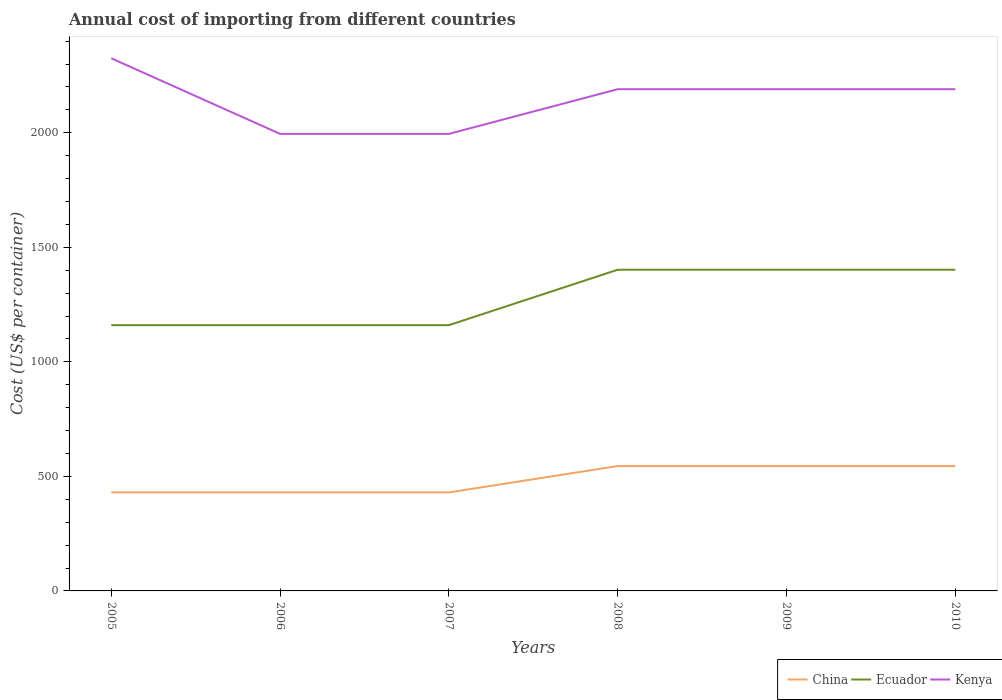Across all years, what is the maximum total annual cost of importing in Ecuador?
Make the answer very short. 1160. In which year was the total annual cost of importing in China maximum?
Provide a succinct answer. 2005. What is the total total annual cost of importing in Kenya in the graph?
Your answer should be compact. 135. What is the difference between the highest and the second highest total annual cost of importing in Kenya?
Keep it short and to the point. 330. What is the difference between the highest and the lowest total annual cost of importing in Ecuador?
Your response must be concise. 3. Is the total annual cost of importing in Kenya strictly greater than the total annual cost of importing in China over the years?
Provide a short and direct response. No. Are the values on the major ticks of Y-axis written in scientific E-notation?
Offer a very short reply. No. Does the graph contain any zero values?
Provide a succinct answer. No. Where does the legend appear in the graph?
Your response must be concise. Bottom right. How many legend labels are there?
Keep it short and to the point. 3. What is the title of the graph?
Offer a very short reply. Annual cost of importing from different countries. What is the label or title of the Y-axis?
Your response must be concise. Cost (US$ per container). What is the Cost (US$ per container) of China in 2005?
Your answer should be very brief. 430. What is the Cost (US$ per container) in Ecuador in 2005?
Your answer should be very brief. 1160. What is the Cost (US$ per container) in Kenya in 2005?
Offer a very short reply. 2325. What is the Cost (US$ per container) in China in 2006?
Give a very brief answer. 430. What is the Cost (US$ per container) of Ecuador in 2006?
Provide a succinct answer. 1160. What is the Cost (US$ per container) of Kenya in 2006?
Keep it short and to the point. 1995. What is the Cost (US$ per container) in China in 2007?
Your response must be concise. 430. What is the Cost (US$ per container) in Ecuador in 2007?
Ensure brevity in your answer.  1160. What is the Cost (US$ per container) in Kenya in 2007?
Keep it short and to the point. 1995. What is the Cost (US$ per container) of China in 2008?
Your response must be concise. 545. What is the Cost (US$ per container) of Ecuador in 2008?
Offer a terse response. 1402. What is the Cost (US$ per container) in Kenya in 2008?
Your answer should be compact. 2190. What is the Cost (US$ per container) in China in 2009?
Offer a terse response. 545. What is the Cost (US$ per container) of Ecuador in 2009?
Offer a terse response. 1402. What is the Cost (US$ per container) in Kenya in 2009?
Offer a terse response. 2190. What is the Cost (US$ per container) of China in 2010?
Provide a short and direct response. 545. What is the Cost (US$ per container) of Ecuador in 2010?
Ensure brevity in your answer.  1402. What is the Cost (US$ per container) in Kenya in 2010?
Your response must be concise. 2190. Across all years, what is the maximum Cost (US$ per container) of China?
Give a very brief answer. 545. Across all years, what is the maximum Cost (US$ per container) in Ecuador?
Your response must be concise. 1402. Across all years, what is the maximum Cost (US$ per container) in Kenya?
Your answer should be very brief. 2325. Across all years, what is the minimum Cost (US$ per container) in China?
Offer a terse response. 430. Across all years, what is the minimum Cost (US$ per container) in Ecuador?
Give a very brief answer. 1160. Across all years, what is the minimum Cost (US$ per container) in Kenya?
Provide a succinct answer. 1995. What is the total Cost (US$ per container) of China in the graph?
Your answer should be compact. 2925. What is the total Cost (US$ per container) in Ecuador in the graph?
Offer a very short reply. 7686. What is the total Cost (US$ per container) of Kenya in the graph?
Make the answer very short. 1.29e+04. What is the difference between the Cost (US$ per container) in China in 2005 and that in 2006?
Your answer should be very brief. 0. What is the difference between the Cost (US$ per container) of Kenya in 2005 and that in 2006?
Provide a short and direct response. 330. What is the difference between the Cost (US$ per container) of Ecuador in 2005 and that in 2007?
Provide a short and direct response. 0. What is the difference between the Cost (US$ per container) in Kenya in 2005 and that in 2007?
Your answer should be very brief. 330. What is the difference between the Cost (US$ per container) in China in 2005 and that in 2008?
Make the answer very short. -115. What is the difference between the Cost (US$ per container) of Ecuador in 2005 and that in 2008?
Keep it short and to the point. -242. What is the difference between the Cost (US$ per container) in Kenya in 2005 and that in 2008?
Offer a very short reply. 135. What is the difference between the Cost (US$ per container) in China in 2005 and that in 2009?
Your response must be concise. -115. What is the difference between the Cost (US$ per container) in Ecuador in 2005 and that in 2009?
Offer a very short reply. -242. What is the difference between the Cost (US$ per container) of Kenya in 2005 and that in 2009?
Your answer should be very brief. 135. What is the difference between the Cost (US$ per container) in China in 2005 and that in 2010?
Provide a succinct answer. -115. What is the difference between the Cost (US$ per container) of Ecuador in 2005 and that in 2010?
Offer a terse response. -242. What is the difference between the Cost (US$ per container) in Kenya in 2005 and that in 2010?
Give a very brief answer. 135. What is the difference between the Cost (US$ per container) of China in 2006 and that in 2007?
Make the answer very short. 0. What is the difference between the Cost (US$ per container) in Ecuador in 2006 and that in 2007?
Provide a short and direct response. 0. What is the difference between the Cost (US$ per container) of China in 2006 and that in 2008?
Your response must be concise. -115. What is the difference between the Cost (US$ per container) of Ecuador in 2006 and that in 2008?
Provide a succinct answer. -242. What is the difference between the Cost (US$ per container) in Kenya in 2006 and that in 2008?
Your response must be concise. -195. What is the difference between the Cost (US$ per container) of China in 2006 and that in 2009?
Keep it short and to the point. -115. What is the difference between the Cost (US$ per container) of Ecuador in 2006 and that in 2009?
Your answer should be very brief. -242. What is the difference between the Cost (US$ per container) in Kenya in 2006 and that in 2009?
Offer a terse response. -195. What is the difference between the Cost (US$ per container) in China in 2006 and that in 2010?
Ensure brevity in your answer.  -115. What is the difference between the Cost (US$ per container) of Ecuador in 2006 and that in 2010?
Give a very brief answer. -242. What is the difference between the Cost (US$ per container) of Kenya in 2006 and that in 2010?
Your answer should be very brief. -195. What is the difference between the Cost (US$ per container) in China in 2007 and that in 2008?
Provide a short and direct response. -115. What is the difference between the Cost (US$ per container) of Ecuador in 2007 and that in 2008?
Ensure brevity in your answer.  -242. What is the difference between the Cost (US$ per container) in Kenya in 2007 and that in 2008?
Your answer should be compact. -195. What is the difference between the Cost (US$ per container) of China in 2007 and that in 2009?
Offer a very short reply. -115. What is the difference between the Cost (US$ per container) of Ecuador in 2007 and that in 2009?
Provide a short and direct response. -242. What is the difference between the Cost (US$ per container) in Kenya in 2007 and that in 2009?
Keep it short and to the point. -195. What is the difference between the Cost (US$ per container) in China in 2007 and that in 2010?
Provide a short and direct response. -115. What is the difference between the Cost (US$ per container) of Ecuador in 2007 and that in 2010?
Your response must be concise. -242. What is the difference between the Cost (US$ per container) of Kenya in 2007 and that in 2010?
Keep it short and to the point. -195. What is the difference between the Cost (US$ per container) of China in 2008 and that in 2009?
Keep it short and to the point. 0. What is the difference between the Cost (US$ per container) of Kenya in 2008 and that in 2009?
Your response must be concise. 0. What is the difference between the Cost (US$ per container) in Kenya in 2008 and that in 2010?
Offer a very short reply. 0. What is the difference between the Cost (US$ per container) of China in 2009 and that in 2010?
Keep it short and to the point. 0. What is the difference between the Cost (US$ per container) of China in 2005 and the Cost (US$ per container) of Ecuador in 2006?
Your answer should be very brief. -730. What is the difference between the Cost (US$ per container) of China in 2005 and the Cost (US$ per container) of Kenya in 2006?
Your answer should be compact. -1565. What is the difference between the Cost (US$ per container) in Ecuador in 2005 and the Cost (US$ per container) in Kenya in 2006?
Ensure brevity in your answer.  -835. What is the difference between the Cost (US$ per container) in China in 2005 and the Cost (US$ per container) in Ecuador in 2007?
Offer a very short reply. -730. What is the difference between the Cost (US$ per container) in China in 2005 and the Cost (US$ per container) in Kenya in 2007?
Give a very brief answer. -1565. What is the difference between the Cost (US$ per container) in Ecuador in 2005 and the Cost (US$ per container) in Kenya in 2007?
Keep it short and to the point. -835. What is the difference between the Cost (US$ per container) in China in 2005 and the Cost (US$ per container) in Ecuador in 2008?
Ensure brevity in your answer.  -972. What is the difference between the Cost (US$ per container) in China in 2005 and the Cost (US$ per container) in Kenya in 2008?
Keep it short and to the point. -1760. What is the difference between the Cost (US$ per container) of Ecuador in 2005 and the Cost (US$ per container) of Kenya in 2008?
Your answer should be very brief. -1030. What is the difference between the Cost (US$ per container) in China in 2005 and the Cost (US$ per container) in Ecuador in 2009?
Offer a terse response. -972. What is the difference between the Cost (US$ per container) of China in 2005 and the Cost (US$ per container) of Kenya in 2009?
Ensure brevity in your answer.  -1760. What is the difference between the Cost (US$ per container) in Ecuador in 2005 and the Cost (US$ per container) in Kenya in 2009?
Ensure brevity in your answer.  -1030. What is the difference between the Cost (US$ per container) in China in 2005 and the Cost (US$ per container) in Ecuador in 2010?
Offer a very short reply. -972. What is the difference between the Cost (US$ per container) of China in 2005 and the Cost (US$ per container) of Kenya in 2010?
Your response must be concise. -1760. What is the difference between the Cost (US$ per container) in Ecuador in 2005 and the Cost (US$ per container) in Kenya in 2010?
Provide a short and direct response. -1030. What is the difference between the Cost (US$ per container) of China in 2006 and the Cost (US$ per container) of Ecuador in 2007?
Offer a very short reply. -730. What is the difference between the Cost (US$ per container) in China in 2006 and the Cost (US$ per container) in Kenya in 2007?
Your answer should be very brief. -1565. What is the difference between the Cost (US$ per container) in Ecuador in 2006 and the Cost (US$ per container) in Kenya in 2007?
Your response must be concise. -835. What is the difference between the Cost (US$ per container) in China in 2006 and the Cost (US$ per container) in Ecuador in 2008?
Offer a terse response. -972. What is the difference between the Cost (US$ per container) in China in 2006 and the Cost (US$ per container) in Kenya in 2008?
Give a very brief answer. -1760. What is the difference between the Cost (US$ per container) of Ecuador in 2006 and the Cost (US$ per container) of Kenya in 2008?
Make the answer very short. -1030. What is the difference between the Cost (US$ per container) in China in 2006 and the Cost (US$ per container) in Ecuador in 2009?
Your response must be concise. -972. What is the difference between the Cost (US$ per container) in China in 2006 and the Cost (US$ per container) in Kenya in 2009?
Give a very brief answer. -1760. What is the difference between the Cost (US$ per container) of Ecuador in 2006 and the Cost (US$ per container) of Kenya in 2009?
Provide a succinct answer. -1030. What is the difference between the Cost (US$ per container) of China in 2006 and the Cost (US$ per container) of Ecuador in 2010?
Offer a terse response. -972. What is the difference between the Cost (US$ per container) of China in 2006 and the Cost (US$ per container) of Kenya in 2010?
Provide a short and direct response. -1760. What is the difference between the Cost (US$ per container) in Ecuador in 2006 and the Cost (US$ per container) in Kenya in 2010?
Provide a short and direct response. -1030. What is the difference between the Cost (US$ per container) in China in 2007 and the Cost (US$ per container) in Ecuador in 2008?
Your answer should be very brief. -972. What is the difference between the Cost (US$ per container) in China in 2007 and the Cost (US$ per container) in Kenya in 2008?
Your answer should be compact. -1760. What is the difference between the Cost (US$ per container) of Ecuador in 2007 and the Cost (US$ per container) of Kenya in 2008?
Ensure brevity in your answer.  -1030. What is the difference between the Cost (US$ per container) of China in 2007 and the Cost (US$ per container) of Ecuador in 2009?
Make the answer very short. -972. What is the difference between the Cost (US$ per container) of China in 2007 and the Cost (US$ per container) of Kenya in 2009?
Your answer should be compact. -1760. What is the difference between the Cost (US$ per container) of Ecuador in 2007 and the Cost (US$ per container) of Kenya in 2009?
Your answer should be compact. -1030. What is the difference between the Cost (US$ per container) in China in 2007 and the Cost (US$ per container) in Ecuador in 2010?
Offer a terse response. -972. What is the difference between the Cost (US$ per container) in China in 2007 and the Cost (US$ per container) in Kenya in 2010?
Your answer should be compact. -1760. What is the difference between the Cost (US$ per container) in Ecuador in 2007 and the Cost (US$ per container) in Kenya in 2010?
Your response must be concise. -1030. What is the difference between the Cost (US$ per container) in China in 2008 and the Cost (US$ per container) in Ecuador in 2009?
Your response must be concise. -857. What is the difference between the Cost (US$ per container) in China in 2008 and the Cost (US$ per container) in Kenya in 2009?
Provide a succinct answer. -1645. What is the difference between the Cost (US$ per container) of Ecuador in 2008 and the Cost (US$ per container) of Kenya in 2009?
Your answer should be very brief. -788. What is the difference between the Cost (US$ per container) in China in 2008 and the Cost (US$ per container) in Ecuador in 2010?
Your answer should be compact. -857. What is the difference between the Cost (US$ per container) of China in 2008 and the Cost (US$ per container) of Kenya in 2010?
Your answer should be compact. -1645. What is the difference between the Cost (US$ per container) in Ecuador in 2008 and the Cost (US$ per container) in Kenya in 2010?
Offer a very short reply. -788. What is the difference between the Cost (US$ per container) in China in 2009 and the Cost (US$ per container) in Ecuador in 2010?
Provide a succinct answer. -857. What is the difference between the Cost (US$ per container) in China in 2009 and the Cost (US$ per container) in Kenya in 2010?
Your answer should be compact. -1645. What is the difference between the Cost (US$ per container) in Ecuador in 2009 and the Cost (US$ per container) in Kenya in 2010?
Make the answer very short. -788. What is the average Cost (US$ per container) in China per year?
Provide a short and direct response. 487.5. What is the average Cost (US$ per container) of Ecuador per year?
Your response must be concise. 1281. What is the average Cost (US$ per container) of Kenya per year?
Offer a very short reply. 2147.5. In the year 2005, what is the difference between the Cost (US$ per container) in China and Cost (US$ per container) in Ecuador?
Keep it short and to the point. -730. In the year 2005, what is the difference between the Cost (US$ per container) of China and Cost (US$ per container) of Kenya?
Make the answer very short. -1895. In the year 2005, what is the difference between the Cost (US$ per container) in Ecuador and Cost (US$ per container) in Kenya?
Your answer should be very brief. -1165. In the year 2006, what is the difference between the Cost (US$ per container) in China and Cost (US$ per container) in Ecuador?
Keep it short and to the point. -730. In the year 2006, what is the difference between the Cost (US$ per container) in China and Cost (US$ per container) in Kenya?
Provide a succinct answer. -1565. In the year 2006, what is the difference between the Cost (US$ per container) of Ecuador and Cost (US$ per container) of Kenya?
Keep it short and to the point. -835. In the year 2007, what is the difference between the Cost (US$ per container) of China and Cost (US$ per container) of Ecuador?
Your response must be concise. -730. In the year 2007, what is the difference between the Cost (US$ per container) of China and Cost (US$ per container) of Kenya?
Ensure brevity in your answer.  -1565. In the year 2007, what is the difference between the Cost (US$ per container) in Ecuador and Cost (US$ per container) in Kenya?
Provide a succinct answer. -835. In the year 2008, what is the difference between the Cost (US$ per container) in China and Cost (US$ per container) in Ecuador?
Make the answer very short. -857. In the year 2008, what is the difference between the Cost (US$ per container) of China and Cost (US$ per container) of Kenya?
Give a very brief answer. -1645. In the year 2008, what is the difference between the Cost (US$ per container) of Ecuador and Cost (US$ per container) of Kenya?
Make the answer very short. -788. In the year 2009, what is the difference between the Cost (US$ per container) of China and Cost (US$ per container) of Ecuador?
Give a very brief answer. -857. In the year 2009, what is the difference between the Cost (US$ per container) in China and Cost (US$ per container) in Kenya?
Your response must be concise. -1645. In the year 2009, what is the difference between the Cost (US$ per container) of Ecuador and Cost (US$ per container) of Kenya?
Your answer should be very brief. -788. In the year 2010, what is the difference between the Cost (US$ per container) of China and Cost (US$ per container) of Ecuador?
Your answer should be very brief. -857. In the year 2010, what is the difference between the Cost (US$ per container) in China and Cost (US$ per container) in Kenya?
Keep it short and to the point. -1645. In the year 2010, what is the difference between the Cost (US$ per container) of Ecuador and Cost (US$ per container) of Kenya?
Provide a short and direct response. -788. What is the ratio of the Cost (US$ per container) of China in 2005 to that in 2006?
Make the answer very short. 1. What is the ratio of the Cost (US$ per container) of Kenya in 2005 to that in 2006?
Keep it short and to the point. 1.17. What is the ratio of the Cost (US$ per container) in Kenya in 2005 to that in 2007?
Provide a succinct answer. 1.17. What is the ratio of the Cost (US$ per container) in China in 2005 to that in 2008?
Give a very brief answer. 0.79. What is the ratio of the Cost (US$ per container) of Ecuador in 2005 to that in 2008?
Give a very brief answer. 0.83. What is the ratio of the Cost (US$ per container) of Kenya in 2005 to that in 2008?
Your response must be concise. 1.06. What is the ratio of the Cost (US$ per container) of China in 2005 to that in 2009?
Your response must be concise. 0.79. What is the ratio of the Cost (US$ per container) in Ecuador in 2005 to that in 2009?
Your answer should be very brief. 0.83. What is the ratio of the Cost (US$ per container) in Kenya in 2005 to that in 2009?
Make the answer very short. 1.06. What is the ratio of the Cost (US$ per container) of China in 2005 to that in 2010?
Provide a short and direct response. 0.79. What is the ratio of the Cost (US$ per container) of Ecuador in 2005 to that in 2010?
Provide a short and direct response. 0.83. What is the ratio of the Cost (US$ per container) in Kenya in 2005 to that in 2010?
Keep it short and to the point. 1.06. What is the ratio of the Cost (US$ per container) of China in 2006 to that in 2008?
Keep it short and to the point. 0.79. What is the ratio of the Cost (US$ per container) of Ecuador in 2006 to that in 2008?
Provide a succinct answer. 0.83. What is the ratio of the Cost (US$ per container) of Kenya in 2006 to that in 2008?
Ensure brevity in your answer.  0.91. What is the ratio of the Cost (US$ per container) in China in 2006 to that in 2009?
Provide a succinct answer. 0.79. What is the ratio of the Cost (US$ per container) of Ecuador in 2006 to that in 2009?
Provide a short and direct response. 0.83. What is the ratio of the Cost (US$ per container) in Kenya in 2006 to that in 2009?
Make the answer very short. 0.91. What is the ratio of the Cost (US$ per container) of China in 2006 to that in 2010?
Make the answer very short. 0.79. What is the ratio of the Cost (US$ per container) in Ecuador in 2006 to that in 2010?
Provide a succinct answer. 0.83. What is the ratio of the Cost (US$ per container) in Kenya in 2006 to that in 2010?
Your answer should be compact. 0.91. What is the ratio of the Cost (US$ per container) in China in 2007 to that in 2008?
Offer a very short reply. 0.79. What is the ratio of the Cost (US$ per container) in Ecuador in 2007 to that in 2008?
Make the answer very short. 0.83. What is the ratio of the Cost (US$ per container) of Kenya in 2007 to that in 2008?
Offer a terse response. 0.91. What is the ratio of the Cost (US$ per container) in China in 2007 to that in 2009?
Your answer should be very brief. 0.79. What is the ratio of the Cost (US$ per container) in Ecuador in 2007 to that in 2009?
Make the answer very short. 0.83. What is the ratio of the Cost (US$ per container) of Kenya in 2007 to that in 2009?
Ensure brevity in your answer.  0.91. What is the ratio of the Cost (US$ per container) in China in 2007 to that in 2010?
Your response must be concise. 0.79. What is the ratio of the Cost (US$ per container) in Ecuador in 2007 to that in 2010?
Offer a terse response. 0.83. What is the ratio of the Cost (US$ per container) in Kenya in 2007 to that in 2010?
Your response must be concise. 0.91. What is the ratio of the Cost (US$ per container) of Ecuador in 2008 to that in 2010?
Your response must be concise. 1. What is the ratio of the Cost (US$ per container) of China in 2009 to that in 2010?
Provide a short and direct response. 1. What is the ratio of the Cost (US$ per container) of Ecuador in 2009 to that in 2010?
Your response must be concise. 1. What is the ratio of the Cost (US$ per container) of Kenya in 2009 to that in 2010?
Your response must be concise. 1. What is the difference between the highest and the second highest Cost (US$ per container) in Kenya?
Your answer should be very brief. 135. What is the difference between the highest and the lowest Cost (US$ per container) in China?
Your answer should be compact. 115. What is the difference between the highest and the lowest Cost (US$ per container) in Ecuador?
Offer a terse response. 242. What is the difference between the highest and the lowest Cost (US$ per container) of Kenya?
Provide a short and direct response. 330. 